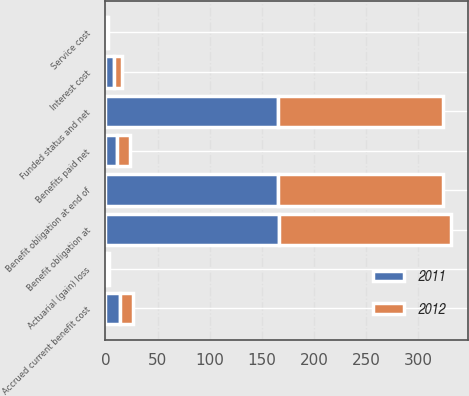<chart> <loc_0><loc_0><loc_500><loc_500><stacked_bar_chart><ecel><fcel>Benefit obligation at<fcel>Service cost<fcel>Interest cost<fcel>Actuarial (gain) loss<fcel>Benefits paid net<fcel>Benefit obligation at end of<fcel>Funded status and net<fcel>Accrued current benefit cost<nl><fcel>2012<fcel>165.2<fcel>1.3<fcel>7.1<fcel>2.9<fcel>11.9<fcel>158.8<fcel>158.8<fcel>12.9<nl><fcel>2011<fcel>166.5<fcel>1.3<fcel>8.3<fcel>0.3<fcel>11.2<fcel>165.2<fcel>165.2<fcel>13.6<nl></chart> 